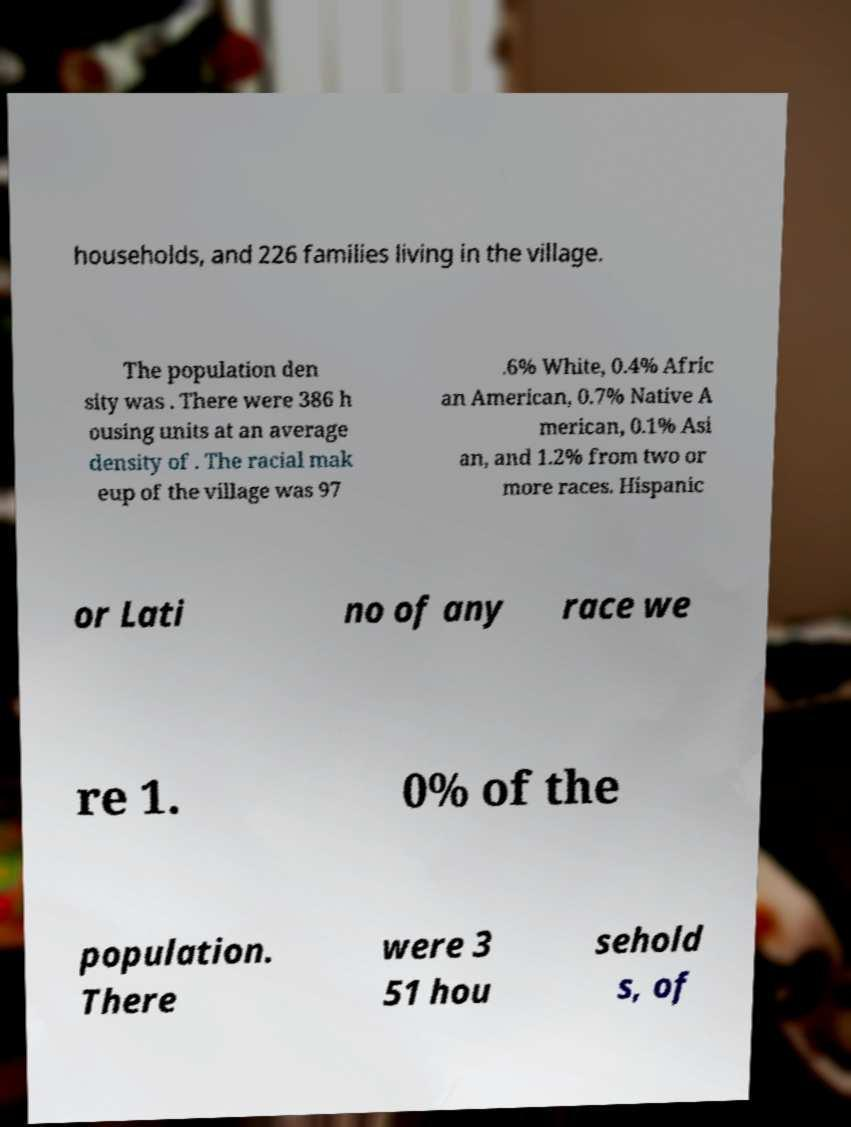There's text embedded in this image that I need extracted. Can you transcribe it verbatim? households, and 226 families living in the village. The population den sity was . There were 386 h ousing units at an average density of . The racial mak eup of the village was 97 .6% White, 0.4% Afric an American, 0.7% Native A merican, 0.1% Asi an, and 1.2% from two or more races. Hispanic or Lati no of any race we re 1. 0% of the population. There were 3 51 hou sehold s, of 